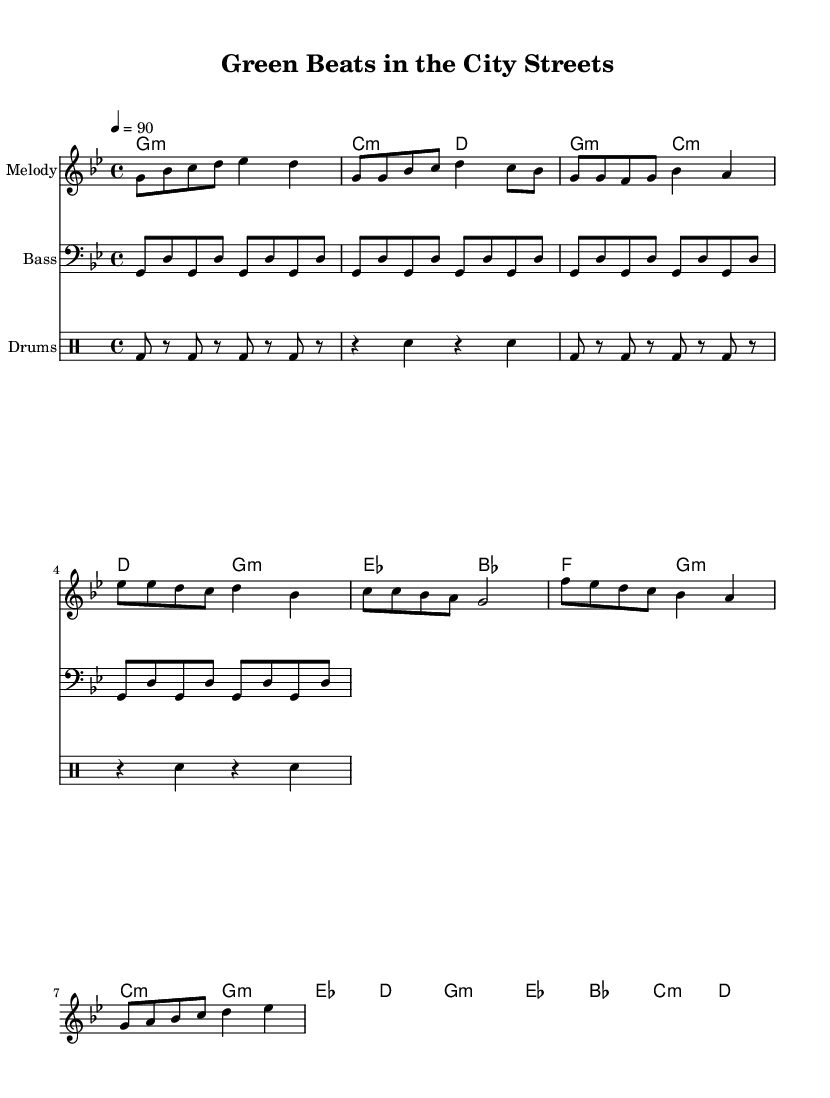What is the key signature of this music? The key signature is G minor, which contains two flats (B flat and E flat).
Answer: G minor What is the time signature of the music? The time signature is 4/4, indicating there are four quarter-note beats in each measure.
Answer: 4/4 What is the tempo marking for this piece? The tempo marking is 4 = 90, meaning the quarter note gets 90 beats per minute.
Answer: 90 How many measures are in the chorus section? The chorus consists of four measures, as seen in the written notes for that section.
Answer: 4 What instrument is indicated for the bass line? The bass line is written for the bass clef, indicating it is played by a bass instrument.
Answer: Bass What is the rhythmic pattern used in the drum section? The drum section predominantly alternates between bass drum and snare drum, creating a typical hip-hop beat.
Answer: Alternating bass and snare Which element of the music emphasizes community themes like urban gardening? The lyrics and musical motifs are designed to convey messages about community gardens and food sovereignty, highlighted in the chorus.
Answer: Chorus 